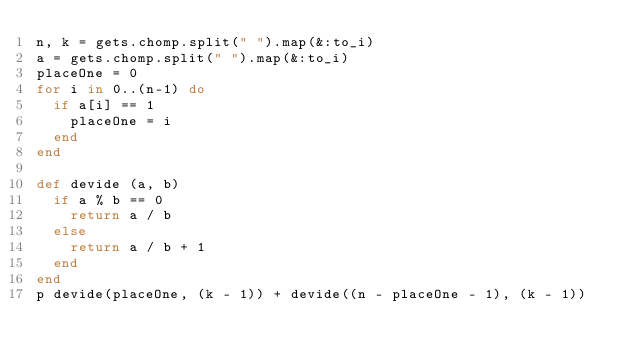Convert code to text. <code><loc_0><loc_0><loc_500><loc_500><_Ruby_>n, k = gets.chomp.split(" ").map(&:to_i)
a = gets.chomp.split(" ").map(&:to_i)
placeOne = 0
for i in 0..(n-1) do
  if a[i] == 1
    placeOne = i
  end
end

def devide (a, b)
  if a % b == 0
    return a / b
  else
    return a / b + 1
  end
end
p devide(placeOne, (k - 1)) + devide((n - placeOne - 1), (k - 1))</code> 